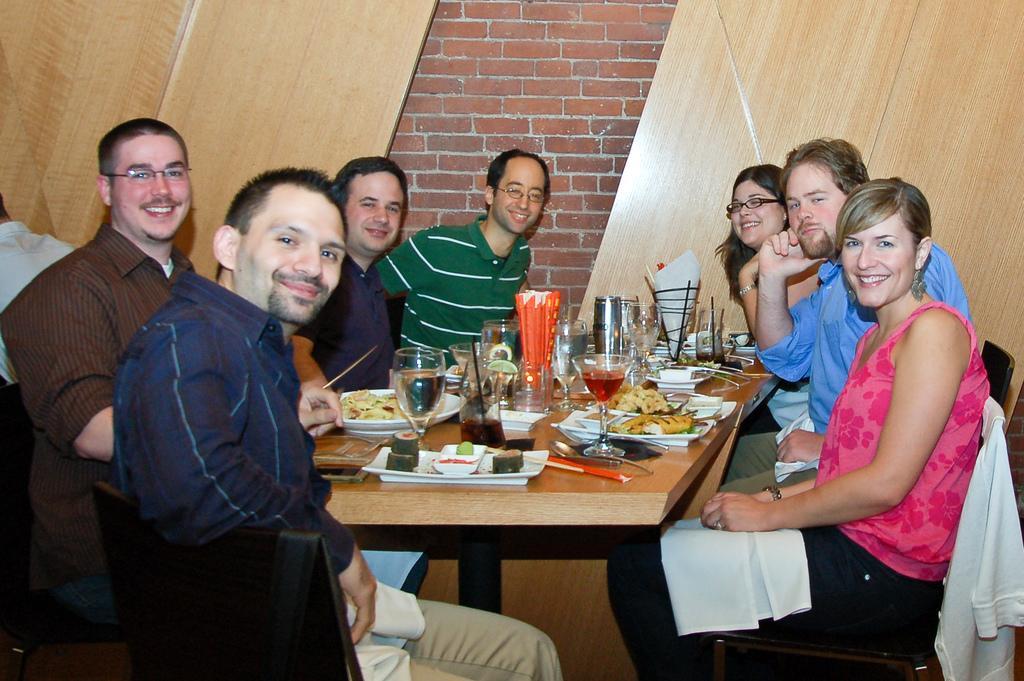Can you describe this image briefly? In this image I can see few people are sitting on the chairs around the table. Everyone are smiling and giving pose for a picture. In the background I can see a wall. On the table I can see some glasses, plates, some food items, bowls and some tissue papers. 